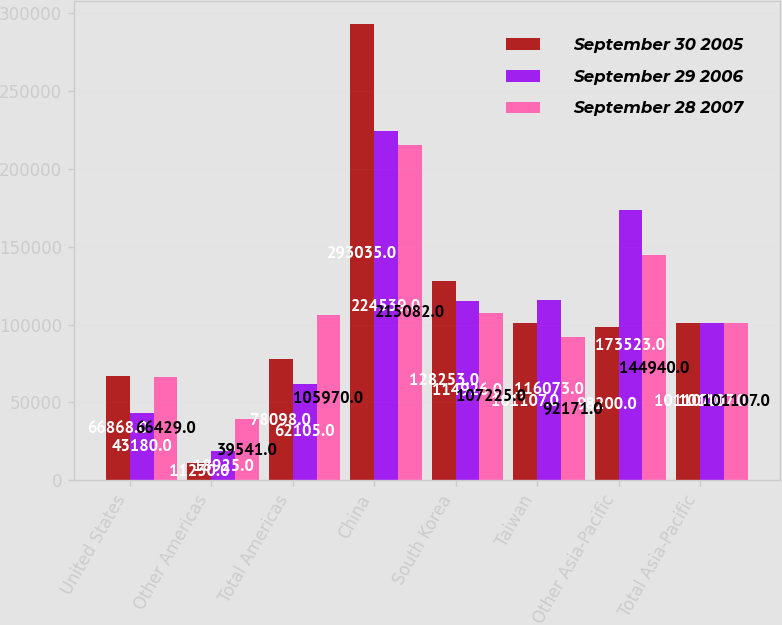Convert chart. <chart><loc_0><loc_0><loc_500><loc_500><stacked_bar_chart><ecel><fcel>United States<fcel>Other Americas<fcel>Total Americas<fcel>China<fcel>South Korea<fcel>Taiwan<fcel>Other Asia-Pacific<fcel>Total Asia-Pacific<nl><fcel>September 30 2005<fcel>66868<fcel>11230<fcel>78098<fcel>293035<fcel>128253<fcel>101107<fcel>98200<fcel>101107<nl><fcel>September 29 2006<fcel>43180<fcel>18925<fcel>62105<fcel>224539<fcel>114926<fcel>116073<fcel>173523<fcel>101107<nl><fcel>September 28 2007<fcel>66429<fcel>39541<fcel>105970<fcel>215082<fcel>107225<fcel>92171<fcel>144940<fcel>101107<nl></chart> 